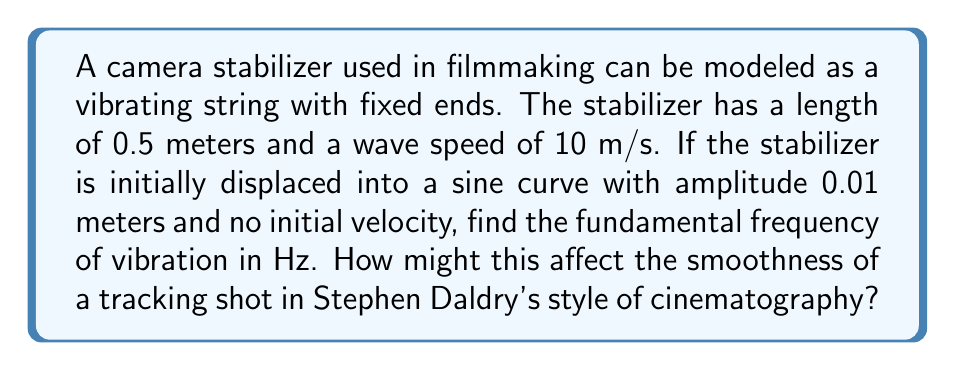Could you help me with this problem? To solve this problem, we'll use the wave equation for a vibrating string with fixed ends:

1) The general form of the wave equation is:
   $$\frac{\partial^2 u}{\partial t^2} = c^2 \frac{\partial^2 u}{\partial x^2}$$
   where $c$ is the wave speed.

2) For a string with fixed ends, the solution has the form:
   $$u(x,t) = \sum_{n=1}^{\infty} A_n \sin(\frac{n\pi x}{L}) \cos(\frac{n\pi c t}{L})$$
   where $L$ is the length of the string.

3) The fundamental frequency corresponds to $n=1$. The frequency $f$ is related to the angular frequency $\omega$ by:
   $$f = \frac{\omega}{2\pi}$$

4) For $n=1$, $\omega = \frac{\pi c}{L}$

5) Substituting the given values:
   $L = 0.5$ m
   $c = 10$ m/s

6) Calculate the fundamental frequency:
   $$f = \frac{\omega}{2\pi} = \frac{\pi c}{2\pi L} = \frac{c}{2L} = \frac{10}{2(0.5)} = 10 \text{ Hz}$$

7) In terms of cinematography, a 10 Hz vibration could introduce noticeable shake in a tracking shot. This frequency is within the range of human visual perception and could create a subtle but potentially distracting movement in the frame. In Stephen Daldry's style, known for its emotional intensity and visual precision (as seen in films like "The Hours" or "Billy Elliot"), such vibration might need to be minimized to maintain the desired aesthetic and narrative focus.
Answer: 10 Hz 